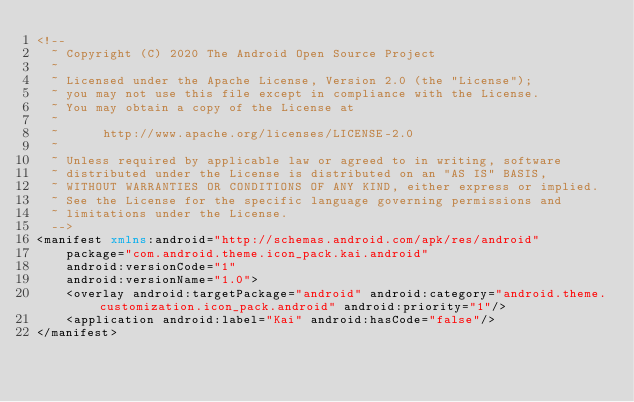Convert code to text. <code><loc_0><loc_0><loc_500><loc_500><_XML_><!--
  ~ Copyright (C) 2020 The Android Open Source Project
  ~
  ~ Licensed under the Apache License, Version 2.0 (the "License");
  ~ you may not use this file except in compliance with the License.
  ~ You may obtain a copy of the License at
  ~
  ~      http://www.apache.org/licenses/LICENSE-2.0
  ~
  ~ Unless required by applicable law or agreed to in writing, software
  ~ distributed under the License is distributed on an "AS IS" BASIS,
  ~ WITHOUT WARRANTIES OR CONDITIONS OF ANY KIND, either express or implied.
  ~ See the License for the specific language governing permissions and
  ~ limitations under the License.
  -->
<manifest xmlns:android="http://schemas.android.com/apk/res/android"
    package="com.android.theme.icon_pack.kai.android"
    android:versionCode="1"
    android:versionName="1.0">
    <overlay android:targetPackage="android" android:category="android.theme.customization.icon_pack.android" android:priority="1"/>
    <application android:label="Kai" android:hasCode="false"/>
</manifest>
</code> 